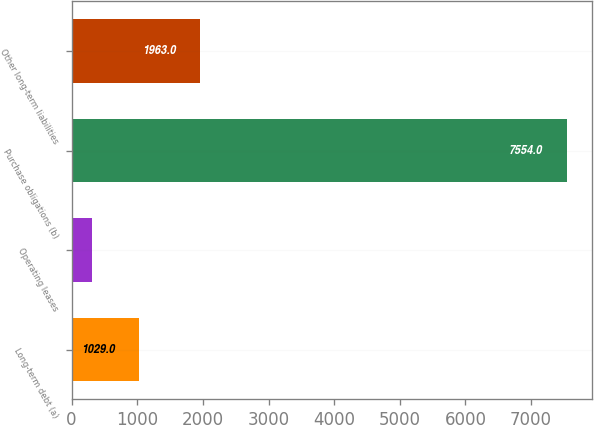<chart> <loc_0><loc_0><loc_500><loc_500><bar_chart><fcel>Long-term debt (a)<fcel>Operating leases<fcel>Purchase obligations (b)<fcel>Other long-term liabilities<nl><fcel>1029<fcel>304<fcel>7554<fcel>1963<nl></chart> 